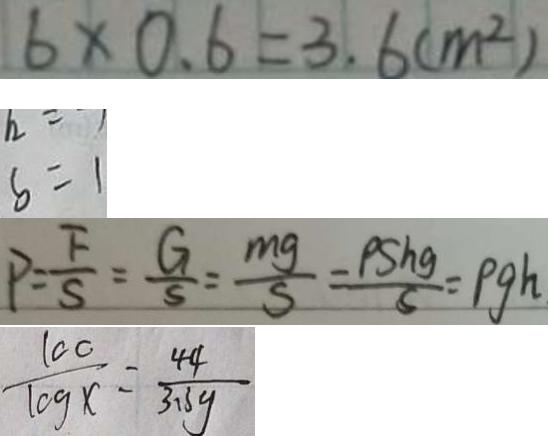<formula> <loc_0><loc_0><loc_500><loc_500>6 \times 0 . 6 = 3 . 6 ( m ^ { 2 } ) 
 b = 1 
 P = \frac { F } { S } = \frac { G } { S } = \frac { m g } { S } = \frac { P S h g } { s } = \rho g h 
 \frac { 1 0 0 } { \log x } = \frac { 4 4 } { 3 1 3 y }</formula> 